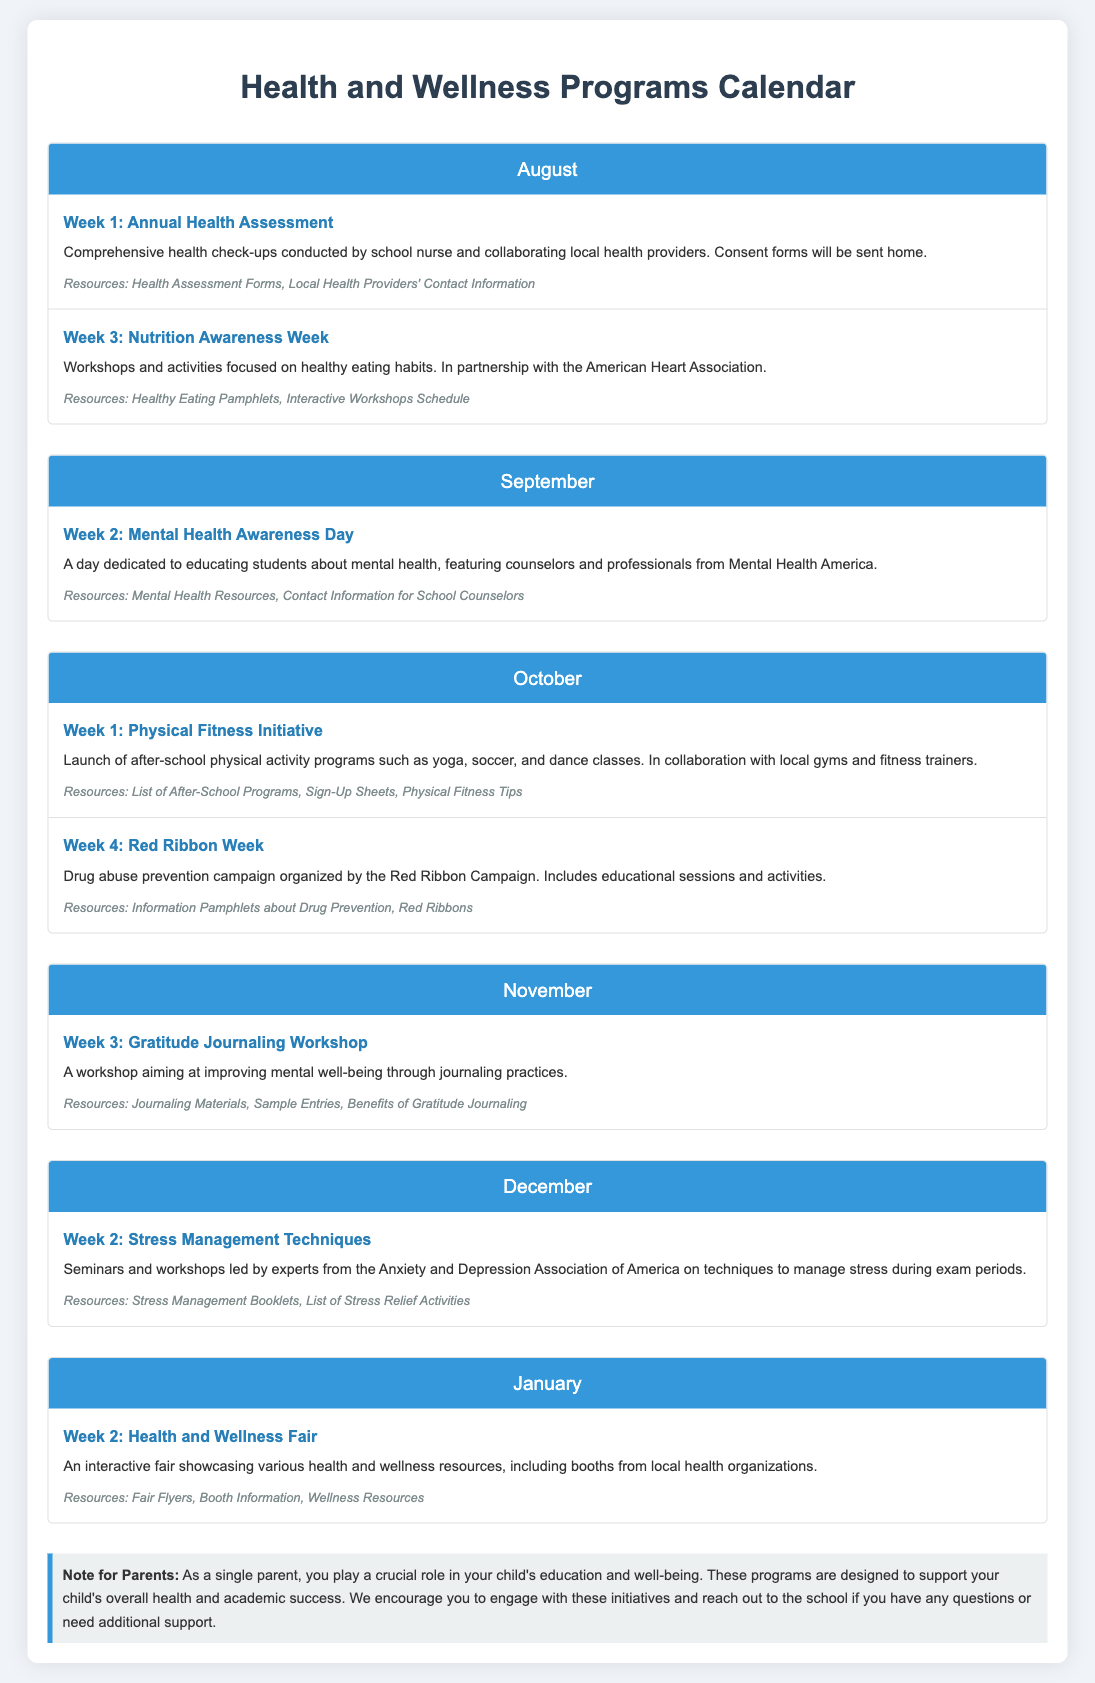what is the first event listed for August? The first event listed for August is "Annual Health Assessment."
Answer: Annual Health Assessment how many weeks are dedicated to events in September? There is one event taking place during September, which is in the second week.
Answer: 1 which organization is involved in Nutrition Awareness Week? Nutrition Awareness Week is in partnership with the American Heart Association.
Answer: American Heart Association what week is the Health and Wellness Fair scheduled for? The Health and Wellness Fair is scheduled for the second week of January.
Answer: Week 2 what type of activities are part of the Physical Fitness Initiative? The Physical Fitness Initiative includes activities such as yoga, soccer, and dance classes.
Answer: yoga, soccer, and dance classes what is the purpose of the Gratitude Journaling Workshop? The purpose of the Gratitude Journaling Workshop is to improve mental well-being through journaling practices.
Answer: improve mental well-being how often do stress management techniques events occur? The events for stress management techniques occur once in December.
Answer: once what specific resources are provided during the Mental Health Awareness Day? Mental Health Awareness Day provides mental health resources and contact information for school counselors.
Answer: Mental Health Resources, Contact Information for School Counselors 